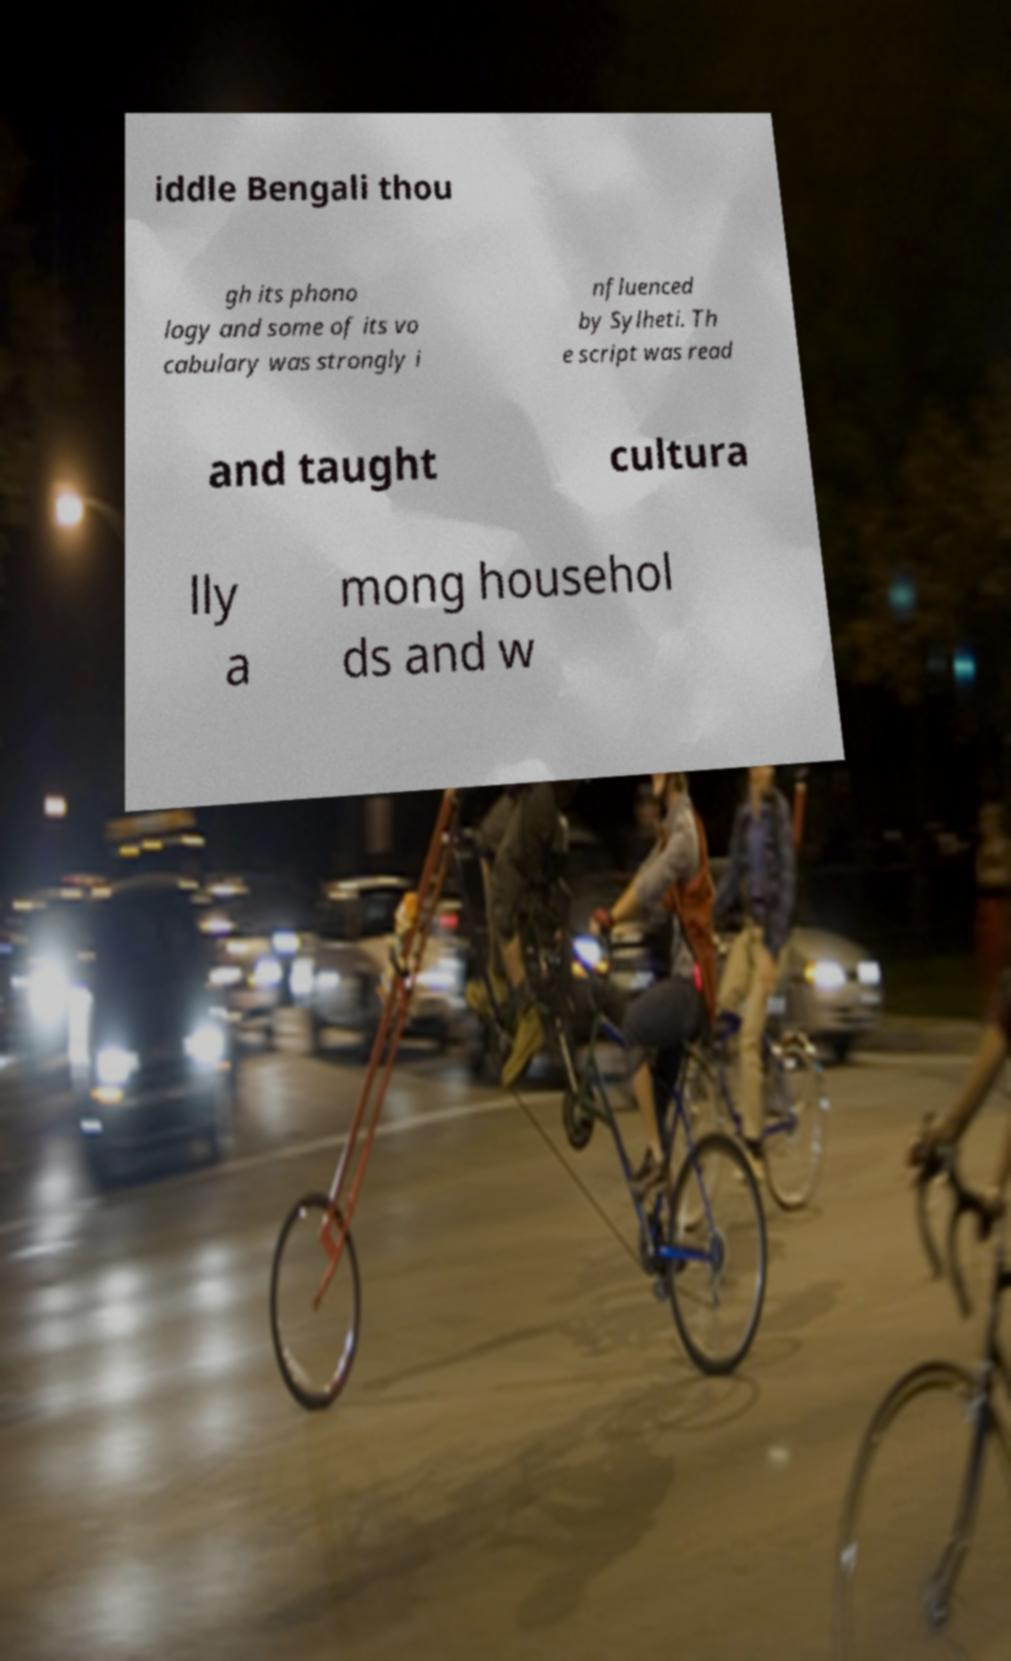Can you accurately transcribe the text from the provided image for me? iddle Bengali thou gh its phono logy and some of its vo cabulary was strongly i nfluenced by Sylheti. Th e script was read and taught cultura lly a mong househol ds and w 